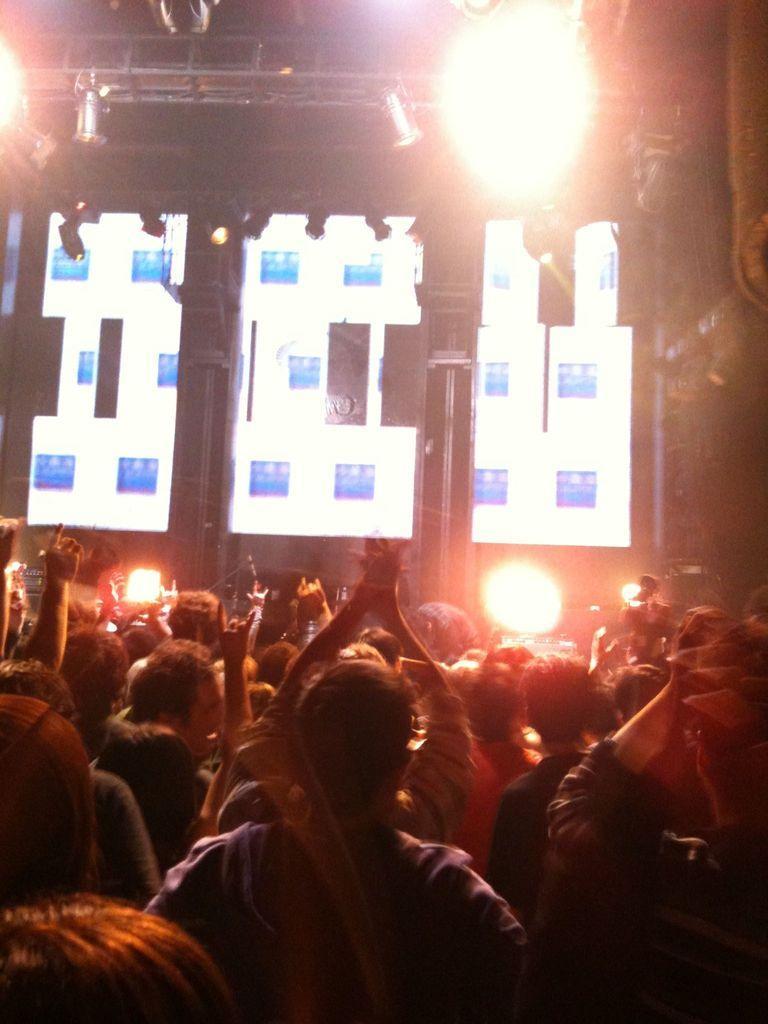Please provide a concise description of this image. This picture is clicked inside the hall. In the foreground we can see the group of persons. In the background we can see the lights and some pictures on the screen and we can see the metal rods, focusing lights and many other objects. 